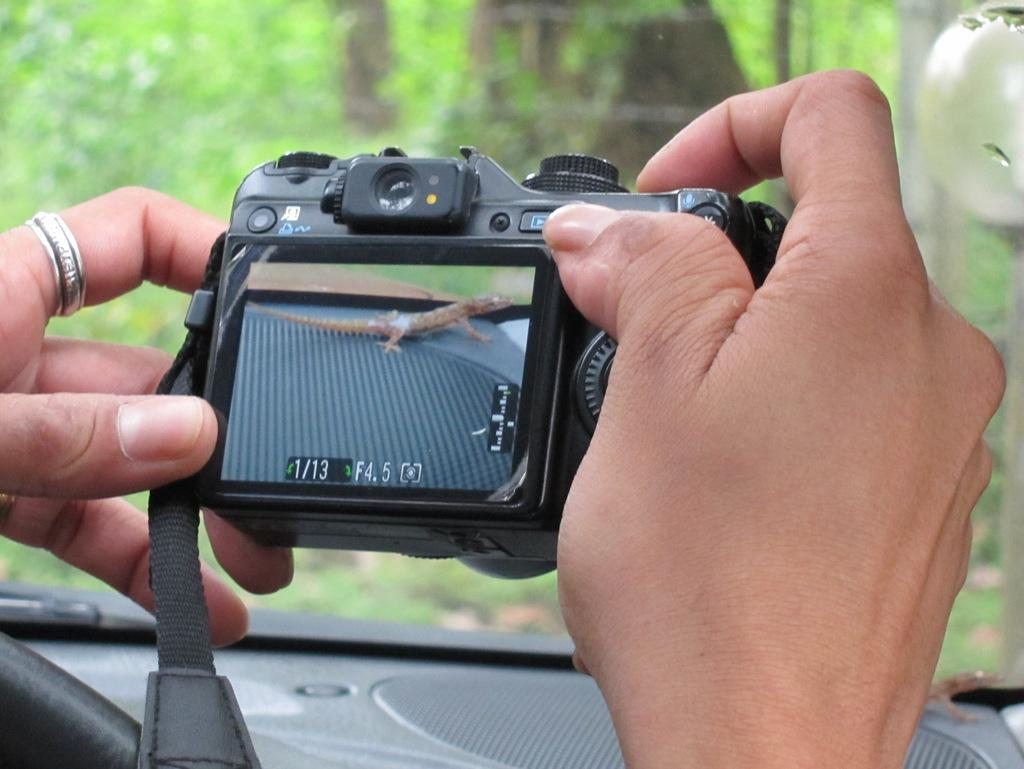Provide a one-sentence caption for the provided image. An unknown brand of digital camera with 4.5 marked as F or possibly shutter speed in a pair of hands. 